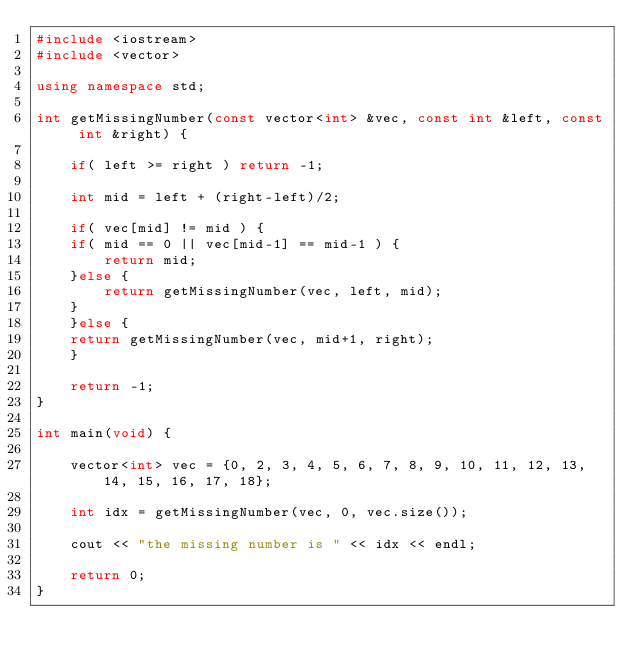Convert code to text. <code><loc_0><loc_0><loc_500><loc_500><_C++_>#include <iostream>
#include <vector>

using namespace std;

int getMissingNumber(const vector<int> &vec, const int &left, const int &right) {

    if( left >= right ) return -1;

    int mid = left + (right-left)/2;

    if( vec[mid] != mid ) {
	if( mid == 0 || vec[mid-1] == mid-1 ) {
	    return mid;
	}else {
	    return getMissingNumber(vec, left, mid);
	}
    }else {
	return getMissingNumber(vec, mid+1, right);
    }

    return -1;
}

int main(void) {

    vector<int> vec = {0, 2, 3, 4, 5, 6, 7, 8, 9, 10, 11, 12, 13, 14, 15, 16, 17, 18};

    int idx = getMissingNumber(vec, 0, vec.size());

    cout << "the missing number is " << idx << endl;

    return 0;
}
</code> 